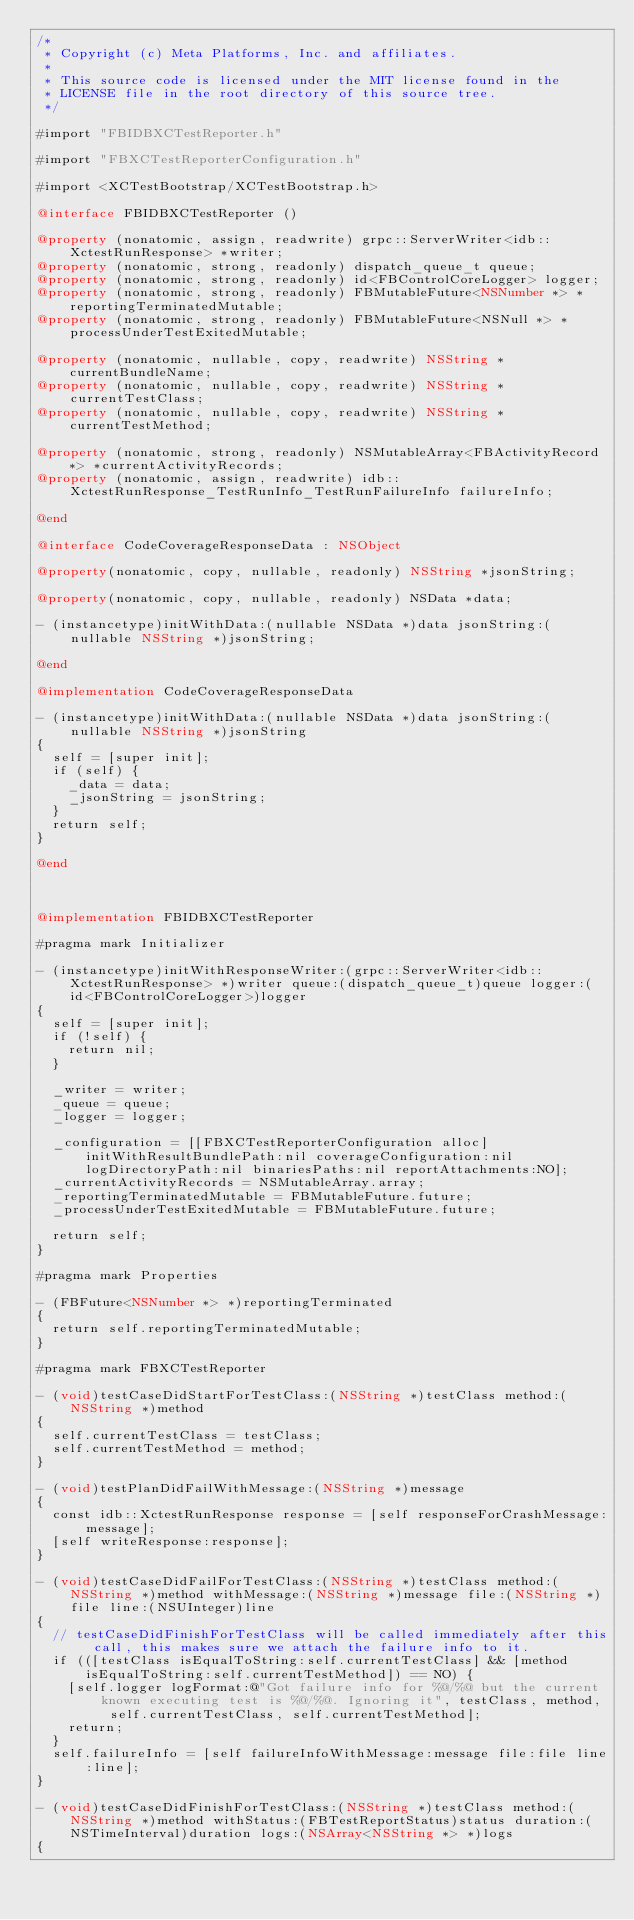<code> <loc_0><loc_0><loc_500><loc_500><_ObjectiveC_>/*
 * Copyright (c) Meta Platforms, Inc. and affiliates.
 *
 * This source code is licensed under the MIT license found in the
 * LICENSE file in the root directory of this source tree.
 */

#import "FBIDBXCTestReporter.h"

#import "FBXCTestReporterConfiguration.h"

#import <XCTestBootstrap/XCTestBootstrap.h>

@interface FBIDBXCTestReporter ()

@property (nonatomic, assign, readwrite) grpc::ServerWriter<idb::XctestRunResponse> *writer;
@property (nonatomic, strong, readonly) dispatch_queue_t queue;
@property (nonatomic, strong, readonly) id<FBControlCoreLogger> logger;
@property (nonatomic, strong, readonly) FBMutableFuture<NSNumber *> *reportingTerminatedMutable;
@property (nonatomic, strong, readonly) FBMutableFuture<NSNull *> *processUnderTestExitedMutable;

@property (nonatomic, nullable, copy, readwrite) NSString *currentBundleName;
@property (nonatomic, nullable, copy, readwrite) NSString *currentTestClass;
@property (nonatomic, nullable, copy, readwrite) NSString *currentTestMethod;

@property (nonatomic, strong, readonly) NSMutableArray<FBActivityRecord *> *currentActivityRecords;
@property (nonatomic, assign, readwrite) idb::XctestRunResponse_TestRunInfo_TestRunFailureInfo failureInfo;

@end

@interface CodeCoverageResponseData : NSObject

@property(nonatomic, copy, nullable, readonly) NSString *jsonString;

@property(nonatomic, copy, nullable, readonly) NSData *data;

- (instancetype)initWithData:(nullable NSData *)data jsonString:(nullable NSString *)jsonString;

@end

@implementation CodeCoverageResponseData

- (instancetype)initWithData:(nullable NSData *)data jsonString:(nullable NSString *)jsonString
{
  self = [super init];
  if (self) {
    _data = data;
    _jsonString = jsonString;
  }
  return self;
}

@end



@implementation FBIDBXCTestReporter

#pragma mark Initializer

- (instancetype)initWithResponseWriter:(grpc::ServerWriter<idb::XctestRunResponse> *)writer queue:(dispatch_queue_t)queue logger:(id<FBControlCoreLogger>)logger
{
  self = [super init];
  if (!self) {
    return nil;
  }

  _writer = writer;
  _queue = queue;
  _logger = logger;

  _configuration = [[FBXCTestReporterConfiguration alloc] initWithResultBundlePath:nil coverageConfiguration:nil logDirectoryPath:nil binariesPaths:nil reportAttachments:NO];
  _currentActivityRecords = NSMutableArray.array;
  _reportingTerminatedMutable = FBMutableFuture.future;
  _processUnderTestExitedMutable = FBMutableFuture.future;

  return self;
}

#pragma mark Properties

- (FBFuture<NSNumber *> *)reportingTerminated
{
  return self.reportingTerminatedMutable;
}

#pragma mark FBXCTestReporter

- (void)testCaseDidStartForTestClass:(NSString *)testClass method:(NSString *)method
{
  self.currentTestClass = testClass;
  self.currentTestMethod = method;
}

- (void)testPlanDidFailWithMessage:(NSString *)message
{
  const idb::XctestRunResponse response = [self responseForCrashMessage:message];
  [self writeResponse:response];
}

- (void)testCaseDidFailForTestClass:(NSString *)testClass method:(NSString *)method withMessage:(NSString *)message file:(NSString *)file line:(NSUInteger)line
{
  // testCaseDidFinishForTestClass will be called immediately after this call, this makes sure we attach the failure info to it.
  if (([testClass isEqualToString:self.currentTestClass] && [method isEqualToString:self.currentTestMethod]) == NO) {
    [self.logger logFormat:@"Got failure info for %@/%@ but the current known executing test is %@/%@. Ignoring it", testClass, method, self.currentTestClass, self.currentTestMethod];
    return;
  }
  self.failureInfo = [self failureInfoWithMessage:message file:file line:line];
}

- (void)testCaseDidFinishForTestClass:(NSString *)testClass method:(NSString *)method withStatus:(FBTestReportStatus)status duration:(NSTimeInterval)duration logs:(NSArray<NSString *> *)logs
{</code> 